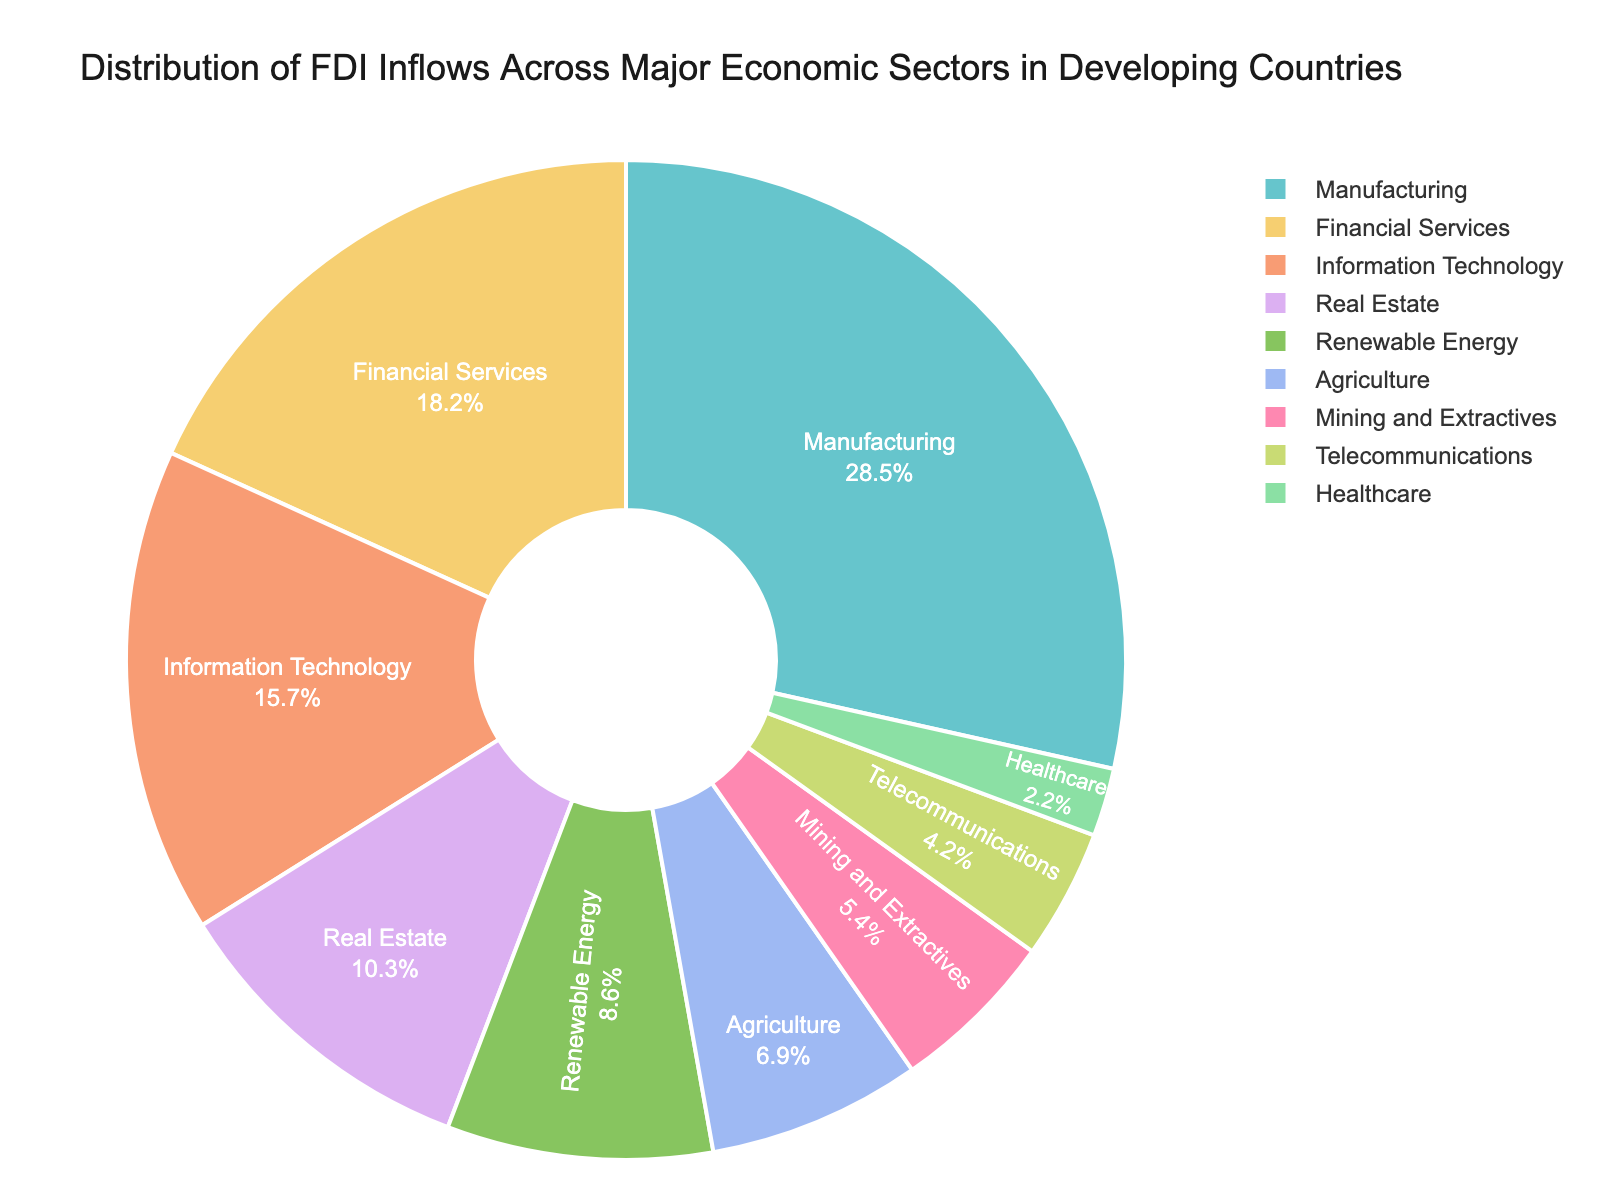What's the percentage of FDI inflows in Financial Services and Real Estate sectors combined? Add the percentages for Financial Services (18.2%) and Real Estate (10.3%). The combined percentage is 18.2 + 10.3 = 28.5%.
Answer: 28.5% Which sector has the highest FDI inflows? Look at the sectors and their corresponding percentages. Manufacturing has the highest at 28.5%.
Answer: Manufacturing How much higher is the FDI inflow in Information Technology compared to Agriculture? Subtract Agriculture's percentage (6.9%) from Information Technology's percentage (15.7%). The difference is 15.7 - 6.9 = 8.8%.
Answer: 8.8% Is the FDI inflow in Telecommunications greater or less than that in Healthcare? Compare the percentages. Telecommunications has 4.2% and Healthcare has 2.2%, so Telecommunications is greater.
Answer: Greater What is the total percentage of FDI inflows in the Renewable Energy, Agriculture, and Mining and Extractives sectors? Sum the percentages for Renewable Energy (8.6%), Agriculture (6.9%), and Mining and Extractives (5.4%). Total percentage is 8.6 + 6.9 + 5.4 = 20.9%.
Answer: 20.9% What’s the percentage difference between the sectors with the second and third highest FDI inflows? Identify the second highest (Financial Services at 18.2%) and the third highest (Information Technology at 15.7%). The difference is 18.2 - 15.7 = 2.5%.
Answer: 2.5% Which sectors jointly constitute more than 25% but less than 35% of the FDI inflows? Look for any combination of sectors whose summed percentages fall between 25% and 35%. Financial Services (18.2%) and Real Estate (10.3%) together sum to 18.2 + 10.3 = 28.5%.
Answer: Financial Services and Real Estate List the sectors with FDI inflows less than 5%. Identify all sectors with percentages less than 5%. Mining and Extractives (5.4%) is slightly more, so only Telecommunications (4.2%) and Healthcare (2.2%) qualify.
Answer: Telecommunications and Healthcare What is the average FDI inflow percentage across all sectors? Sum all percentages and divide by the number of sectors. Sum = 28.5 + 18.2 + 15.7 + 10.3 + 8.6 + 6.9 + 5.4 + 4.2 + 2.2 = 100%. There are 9 sectors, so 100/9 ≈ 11.1%.
Answer: 11.1% Which sector has roughly half the FDI inflow percentage of the highest sector? The highest is Manufacturing (28.5%). Look for a sector with around 14.25%. Information Technology closest with 15.7%. Manufacturing's half is approximately 14.25%.
Answer: Information Technology 